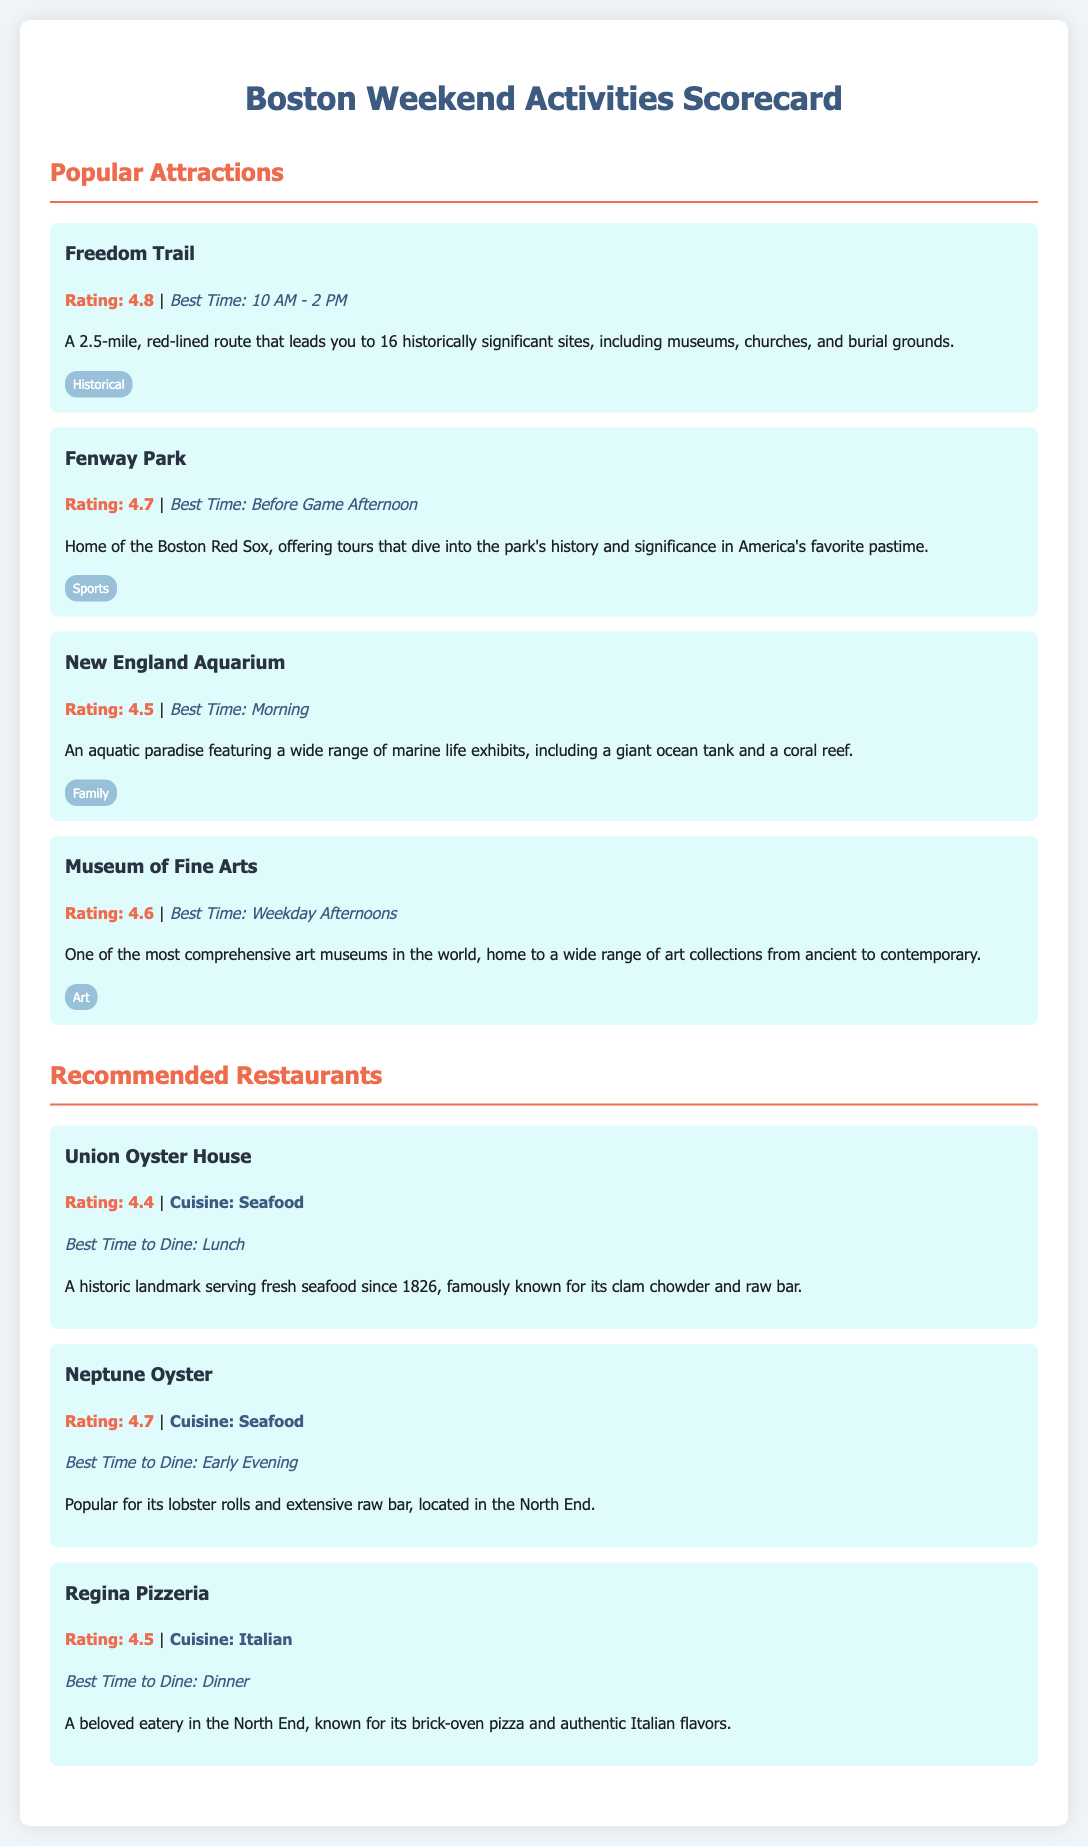What is the rating of the Freedom Trail? The rating is stated directly in the document under the Freedom Trail section.
Answer: 4.8 What is the best time to visit Fenway Park? The best time is mentioned in the context of visiting Fenway Park.
Answer: Before Game Afternoon How many attractions are listed in the document? The document lists four attractions under the Popular Attractions section.
Answer: 4 Which restaurant is known for its clam chowder? The restaurant known for its clam chowder is specified in the Union Oyster House description.
Answer: Union Oyster House What is the cuisine of Regina Pizzeria? The cuisine type is indicated in the Regina Pizzeria description.
Answer: Italian Which attraction has the best rating? The question involves comparing the ratings of all attractions listed.
Answer: Freedom Trail What is the recommended time to dine at Neptune Oyster? This involves looking for the suggested dining time mentioned for Neptune Oyster.
Answer: Early Evening What type of establishment is the Museum of Fine Arts? The document categorizes the Museum of Fine Arts under a specific type of attraction.
Answer: Art 